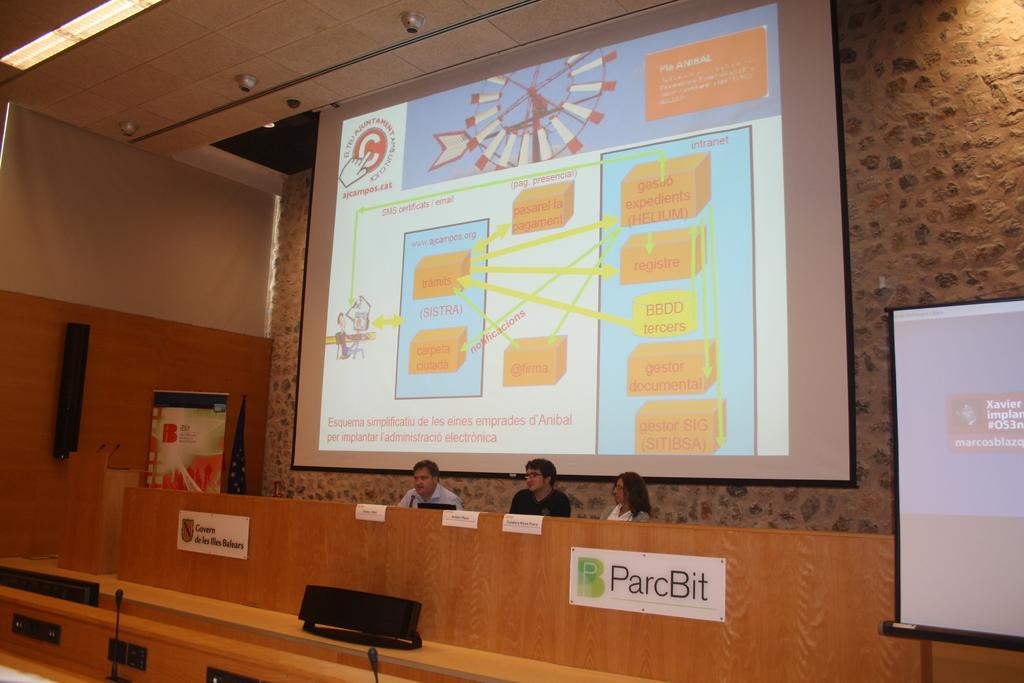Please provide a concise description of this image. In this image I can see few persons sitting in front of a desk and on the desk I can see few objects and few microphones. I can see few boards attached to the desk. I can see two huge screens, the wall, the ceiling, few lights to the ceiling, a flag, few speakers and few microphones. 